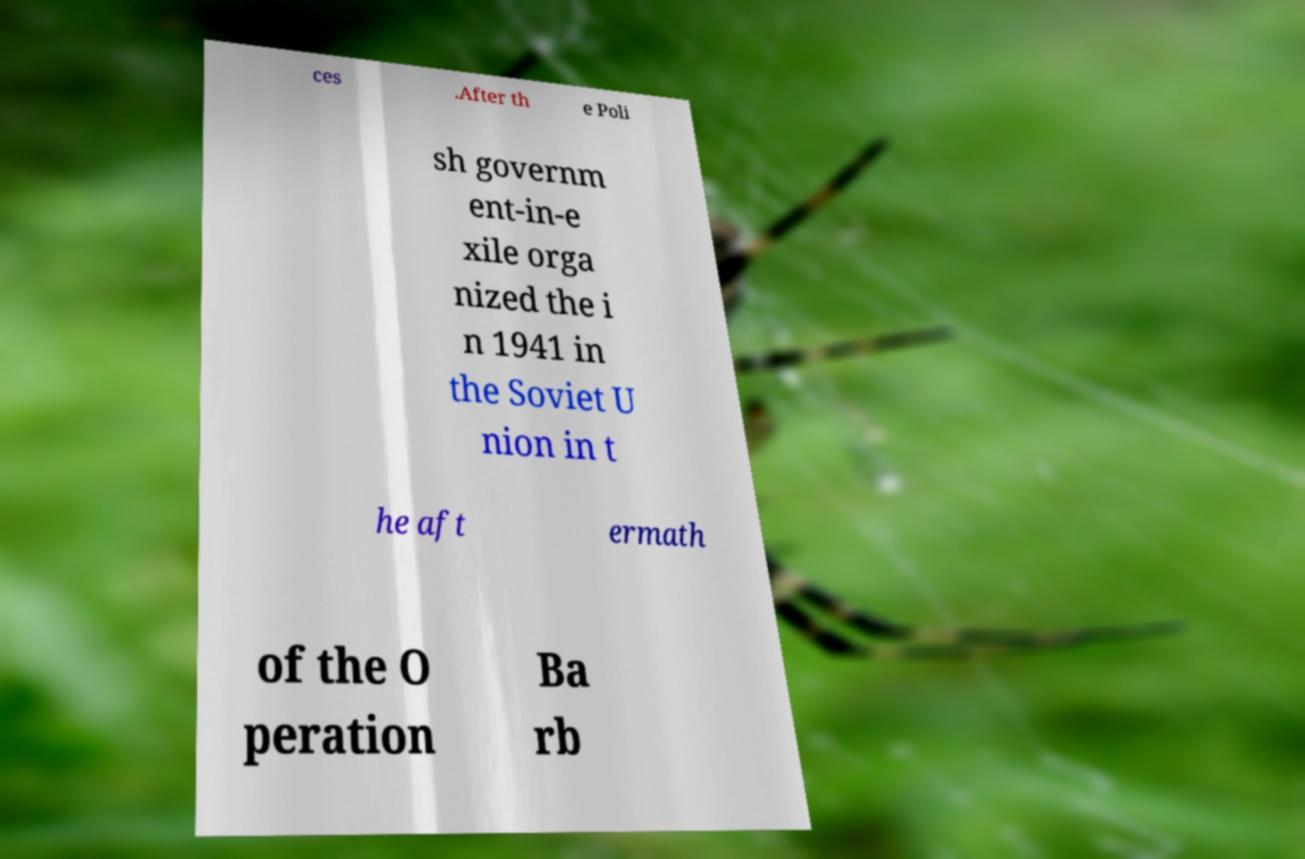Could you assist in decoding the text presented in this image and type it out clearly? ces .After th e Poli sh governm ent-in-e xile orga nized the i n 1941 in the Soviet U nion in t he aft ermath of the O peration Ba rb 